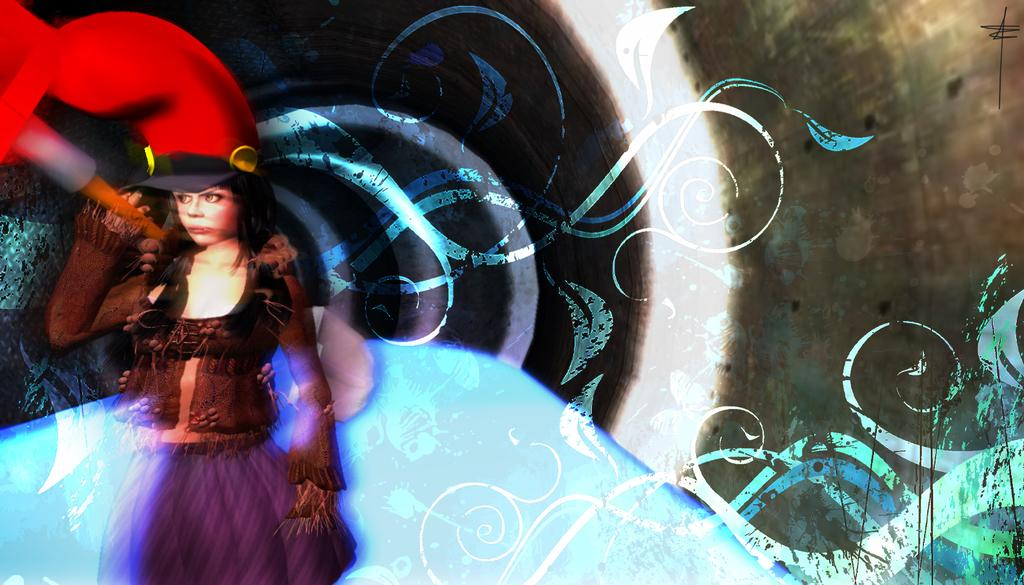Who is present in the image? There is a woman in the image. What is the woman doing in the image? The woman is standing in the image. What is the woman wearing in the image? The woman is wearing clothes and a hat in the image. Can you describe the background of the image? The background of the image has a decorative design. What songs is the minister singing in the image? There is no minister or singing present in the image; it features a woman standing with a decorative background. 